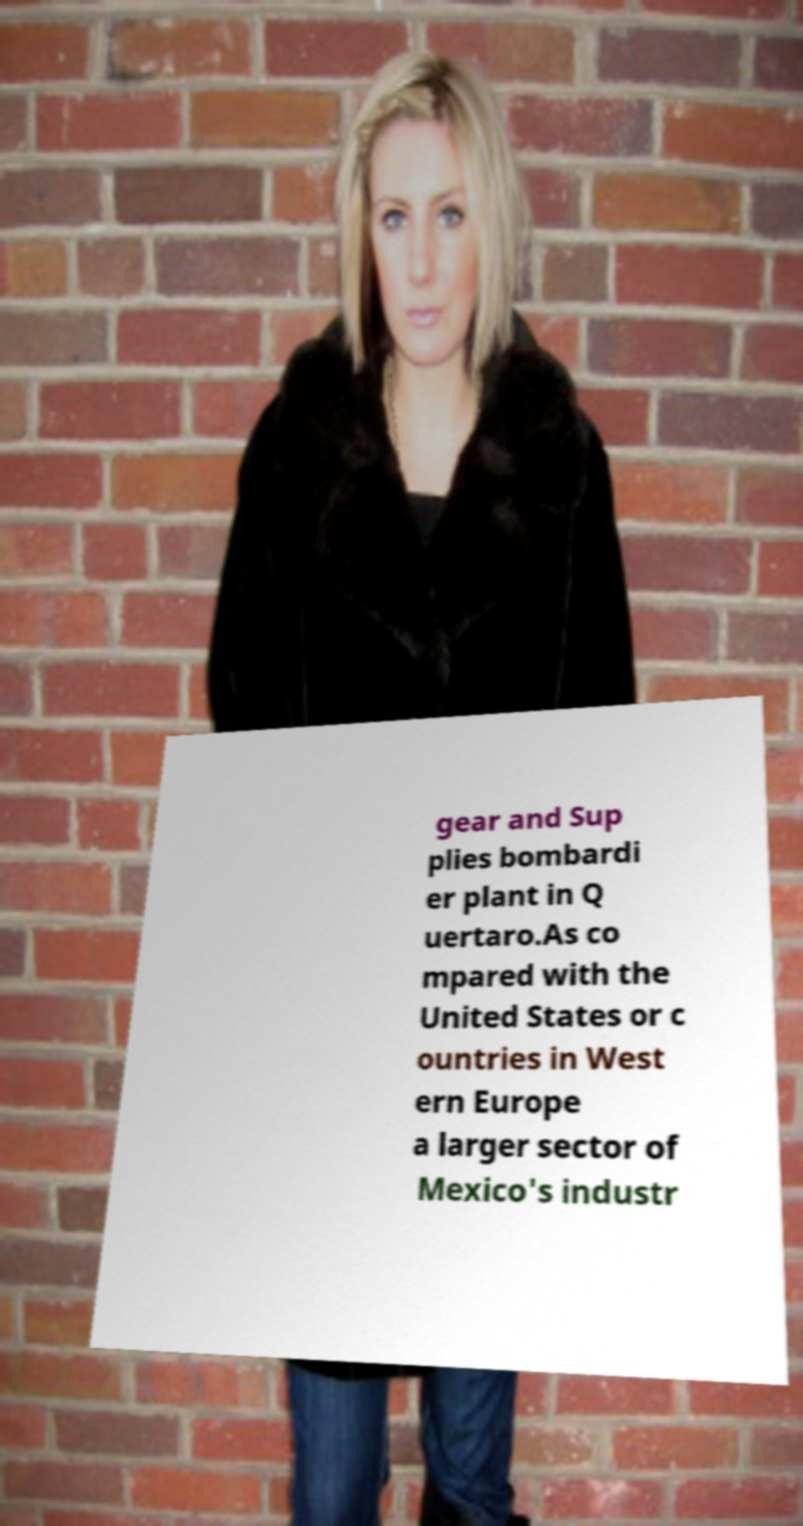Please identify and transcribe the text found in this image. gear and Sup plies bombardi er plant in Q uertaro.As co mpared with the United States or c ountries in West ern Europe a larger sector of Mexico's industr 